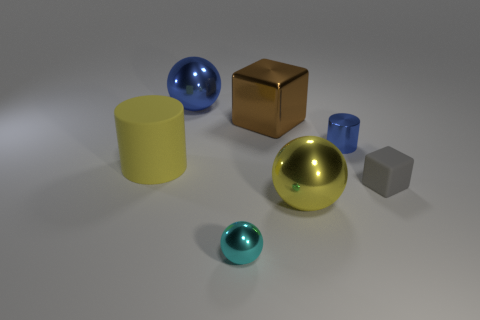Which objects in the image have reflective surfaces? The blue and turquoise spheres, the yellow cylinder, and the golden cube all have reflective surfaces, as indicated by the light spots and the reflections on their surfaces. The gray cube seems to have a matte finish as it does not reflect light in the same manner. How does the color palette of the objects contribute to the overall composition of the image? The color palette in the image is quite diverse, featuring cool tones like blue and turquoise, and warm tones like yellow and golden. This mix of cool and warm colors creates a visually balanced and harmonious composition, especially against the neutral backdrop. 